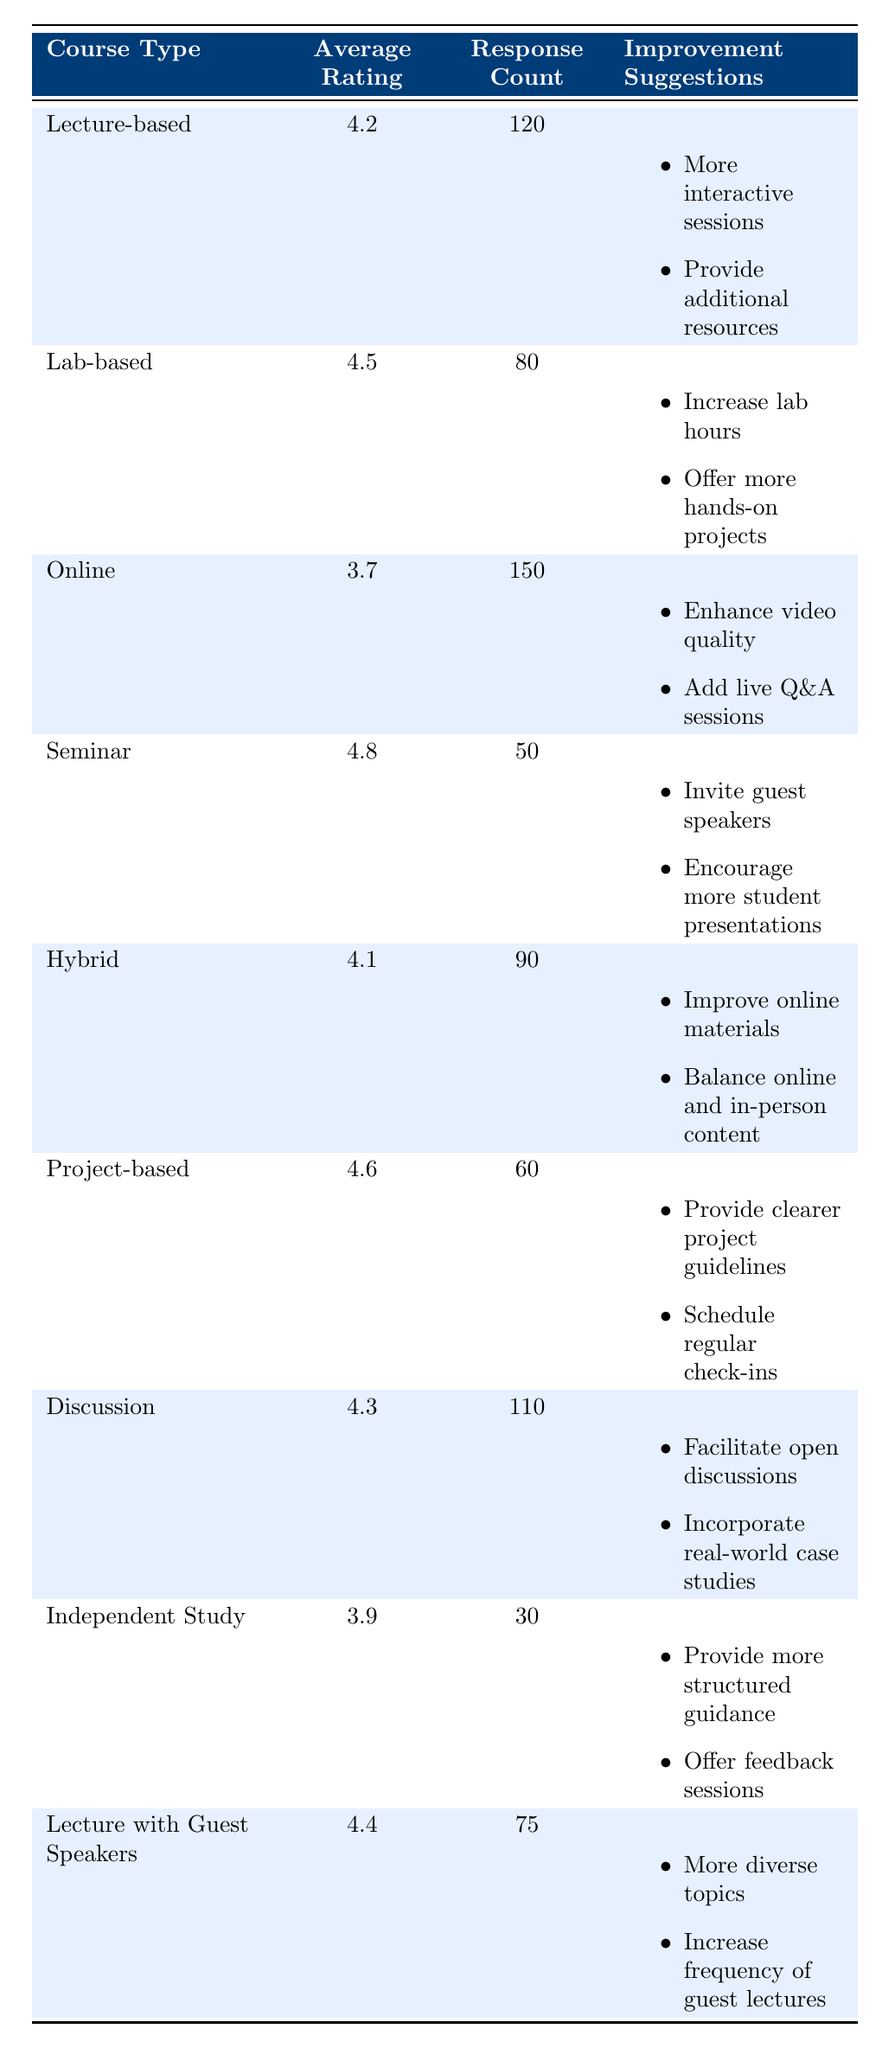What is the average rating for the seminar course type? The table shows that the average rating for the seminar course type is 4.8.
Answer: 4.8 How many responses were collected for the lab-based course type? The response count for the lab-based course type is clearly stated in the table as 80.
Answer: 80 Which course type has the lowest average rating? The online course type has the lowest average rating of 3.7, according to the table.
Answer: Online What is the average rating of lecture-based and discussion courses combined? The average rating for lecture-based courses is 4.2, while discussion courses have an average rating of 4.3. To find the combined average, we add the ratings (4.2 + 4.3 = 8.5) and divide by 2. So, the combined average is 8.5 / 2 = 4.25.
Answer: 4.25 Did all course types receive more than 50 responses? Upon reviewing the response counts, seminar (50) and independent study (30) did not exceed 50 responses. Therefore, the statement is false.
Answer: No What improvement suggestion was made for the online course type? The table indicates two improvement suggestions for the online course type: enhance video quality and add live Q&A sessions.
Answer: Enhance video quality and add live Q&A sessions Which course has the highest average rating, and how much higher is it than the next highest? The seminar course type has the highest average rating of 4.8. The next highest rating is for the project-based course with 4.6. The difference is 4.8 - 4.6 = 0.2.
Answer: Seminar, 0.2 How many suggestions were listed for project-based and lecture with guest speakers course types combined? The project-based course type has 2 suggestions: provide clearer project guidelines and schedule regular check-ins. Similarly, the lecture with guest speakers type also has 2 suggestions: more diverse topics and increase frequency of guest lectures. Together, this gives us a total of 2 + 2 = 4 suggestions combined.
Answer: 4 What percentage of the total responses was from the independent study course type? The total responses can be calculated by summing up the response counts (120 + 80 + 150 + 50 + 90 + 60 + 30 + 75 = 605). The independent study course type has a response count of 30. The percentage is (30 / 605) * 100%, which equals approximately 4.96%.
Answer: Approximately 4.96% 